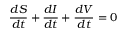<formula> <loc_0><loc_0><loc_500><loc_500>\frac { d S } { d t } + \frac { d I } { d t } + \frac { d V } { d t } = 0</formula> 